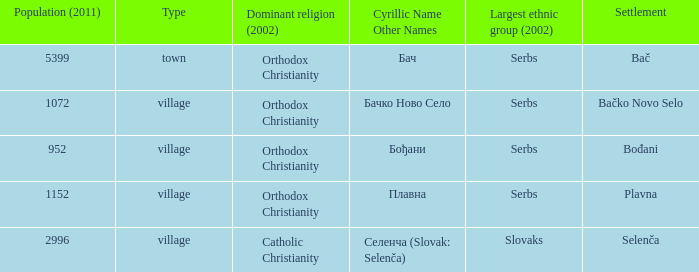What is the second way of writting плавна. Plavna. Write the full table. {'header': ['Population (2011)', 'Type', 'Dominant religion (2002)', 'Cyrillic Name Other Names', 'Largest ethnic group (2002)', 'Settlement'], 'rows': [['5399', 'town', 'Orthodox Christianity', 'Бач', 'Serbs', 'Bač'], ['1072', 'village', 'Orthodox Christianity', 'Бачко Ново Село', 'Serbs', 'Bačko Novo Selo'], ['952', 'village', 'Orthodox Christianity', 'Бођани', 'Serbs', 'Bođani'], ['1152', 'village', 'Orthodox Christianity', 'Плавна', 'Serbs', 'Plavna'], ['2996', 'village', 'Catholic Christianity', 'Селенча (Slovak: Selenča)', 'Slovaks', 'Selenča']]} 